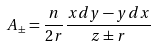Convert formula to latex. <formula><loc_0><loc_0><loc_500><loc_500>A _ { \pm } = \frac { n } { 2 r } \frac { x d y - y d x } { z \pm r }</formula> 